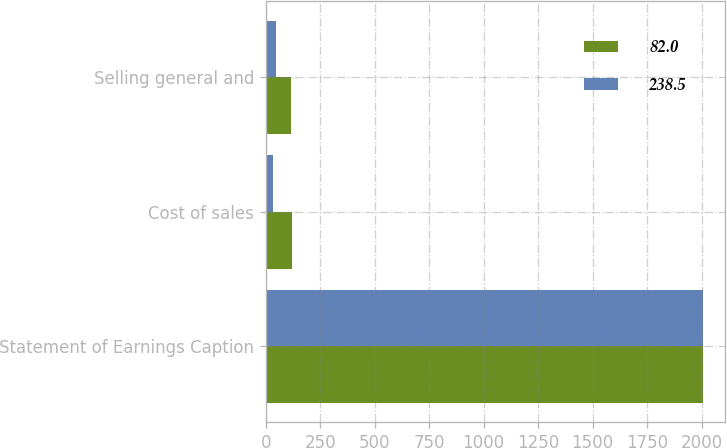<chart> <loc_0><loc_0><loc_500><loc_500><stacked_bar_chart><ecel><fcel>Statement of Earnings Caption<fcel>Cost of sales<fcel>Selling general and<nl><fcel>82<fcel>2009<fcel>121.8<fcel>116.7<nl><fcel>238.5<fcel>2008<fcel>33.1<fcel>48.9<nl></chart> 